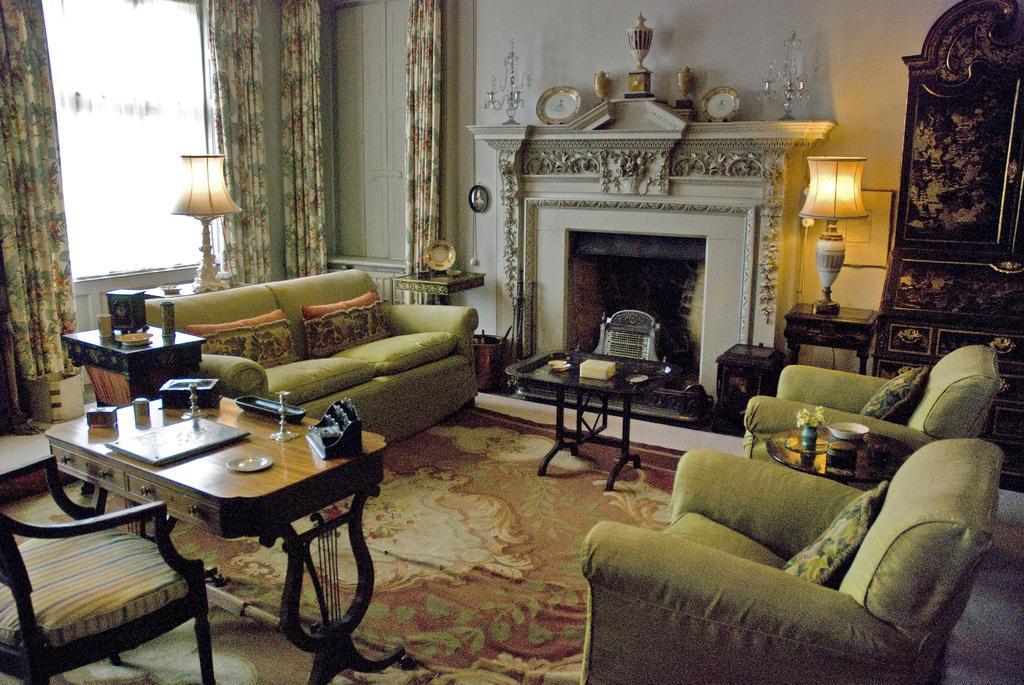Please provide a concise description of this image. This is inside of the room we can see sofa,chairs,tables on the floor,on the table we can see lamps and objects and we can see wall,curtain,glass window,clocks and furniture. 